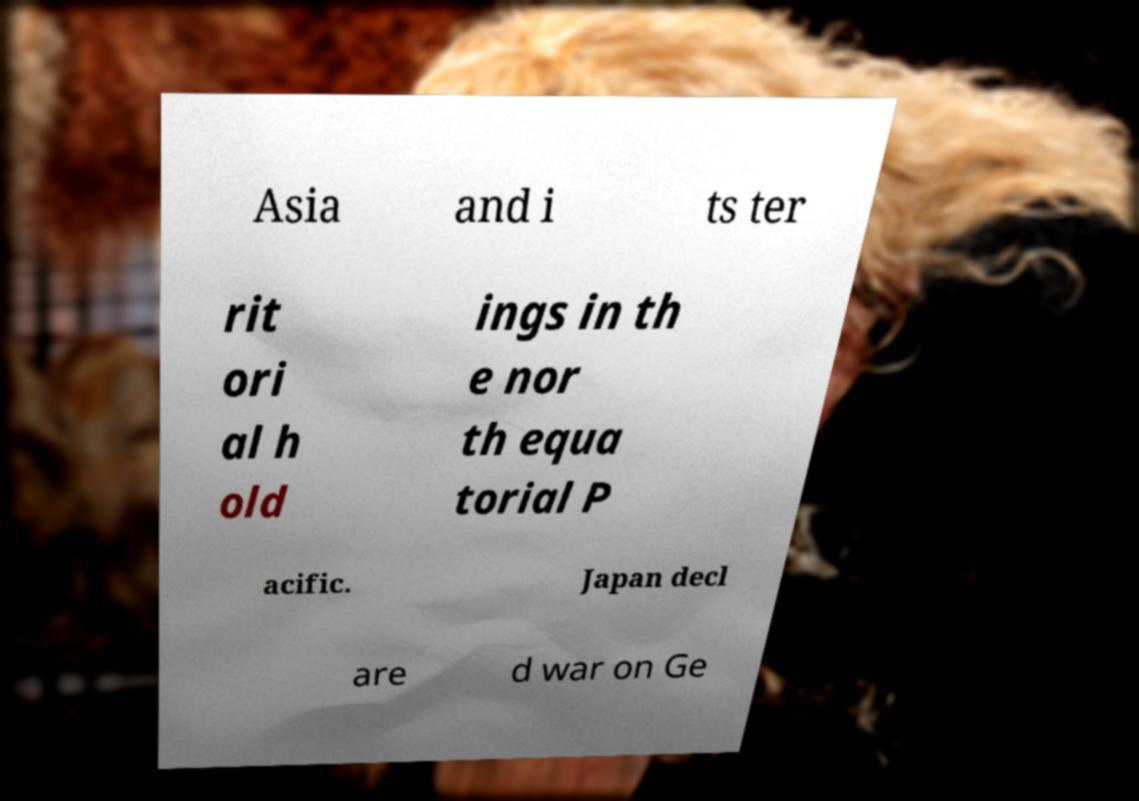Can you accurately transcribe the text from the provided image for me? Asia and i ts ter rit ori al h old ings in th e nor th equa torial P acific. Japan decl are d war on Ge 